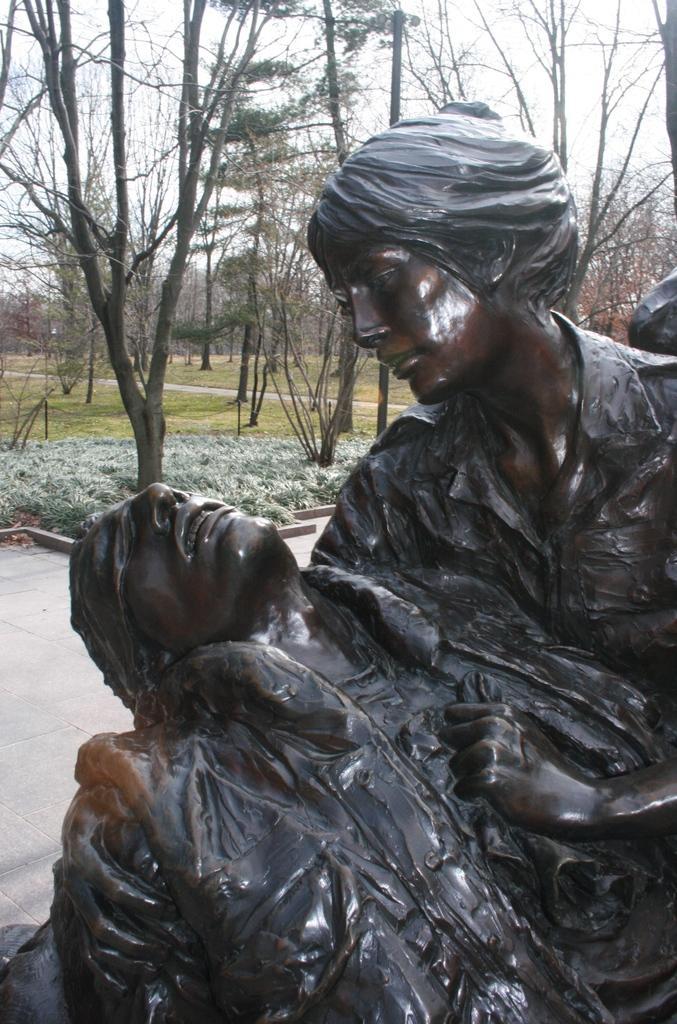Describe this image in one or two sentences. This picture is clicked outside. In the foreground we can see the sculptures of two persons. In the background we can see the grass, trees, sky and some other objects. 